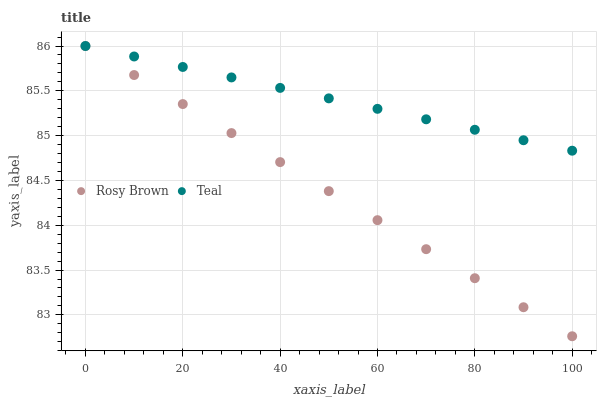Does Rosy Brown have the minimum area under the curve?
Answer yes or no. Yes. Does Teal have the maximum area under the curve?
Answer yes or no. Yes. Does Teal have the minimum area under the curve?
Answer yes or no. No. Is Rosy Brown the smoothest?
Answer yes or no. Yes. Is Teal the roughest?
Answer yes or no. Yes. Is Teal the smoothest?
Answer yes or no. No. Does Rosy Brown have the lowest value?
Answer yes or no. Yes. Does Teal have the lowest value?
Answer yes or no. No. Does Teal have the highest value?
Answer yes or no. Yes. Does Rosy Brown intersect Teal?
Answer yes or no. Yes. Is Rosy Brown less than Teal?
Answer yes or no. No. Is Rosy Brown greater than Teal?
Answer yes or no. No. 